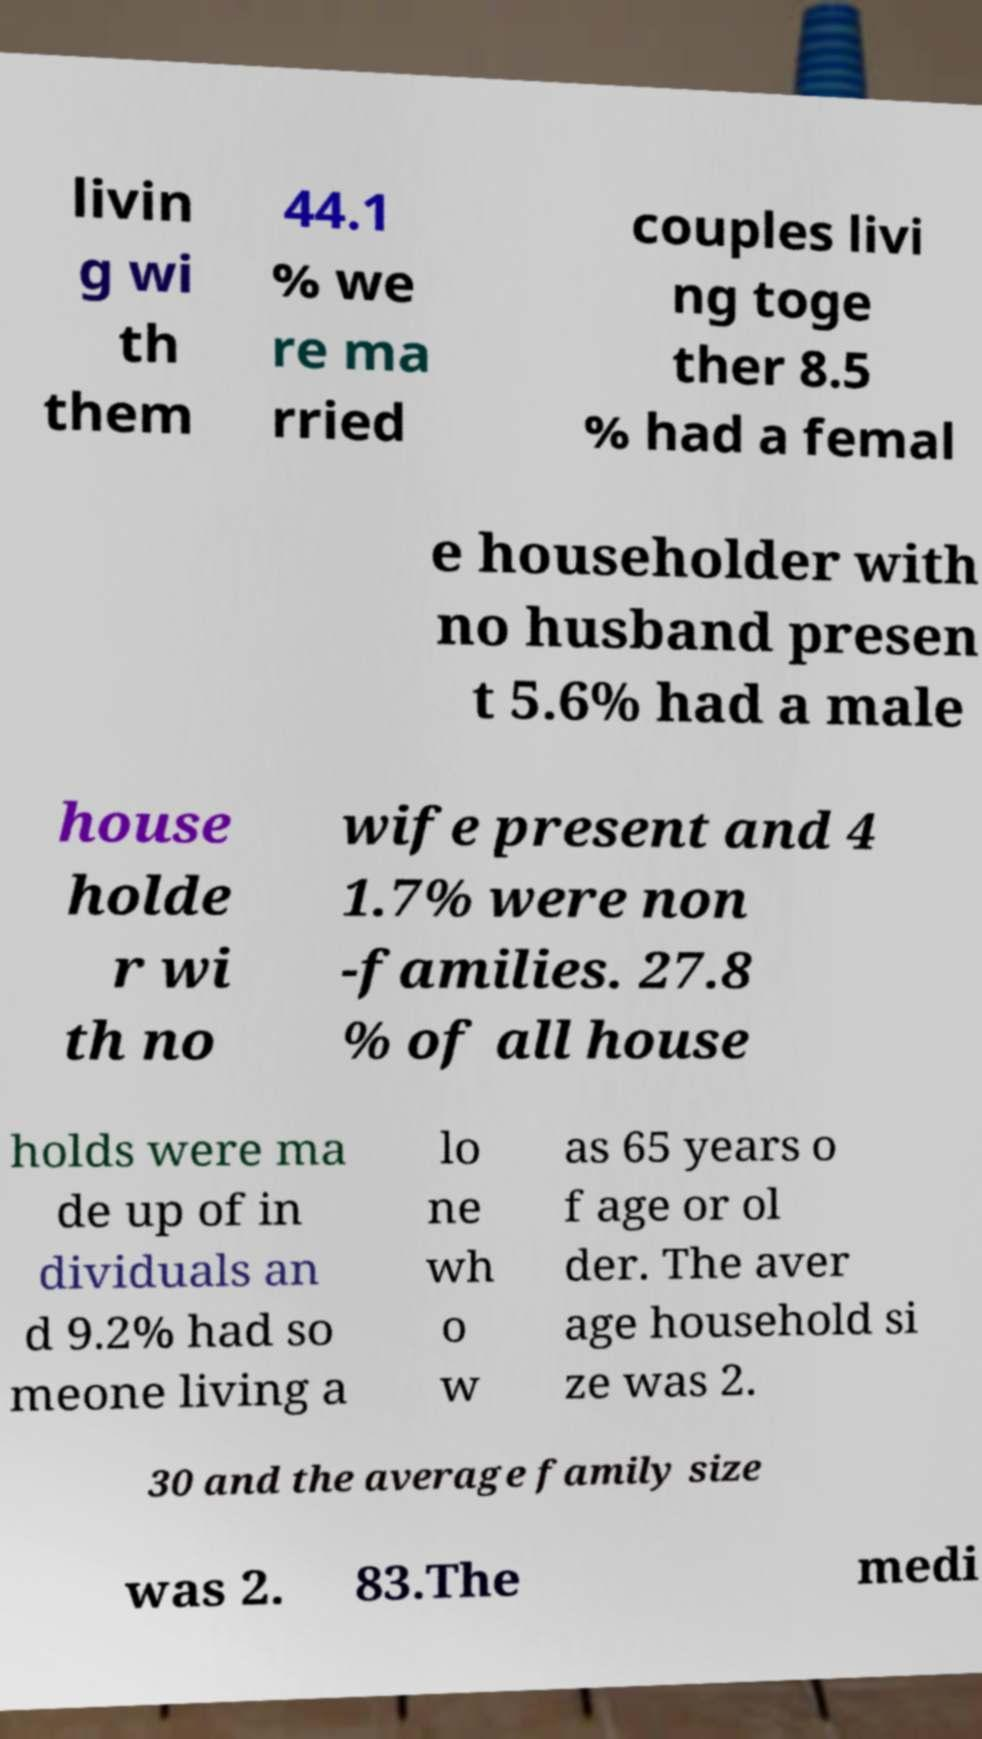For documentation purposes, I need the text within this image transcribed. Could you provide that? livin g wi th them 44.1 % we re ma rried couples livi ng toge ther 8.5 % had a femal e householder with no husband presen t 5.6% had a male house holde r wi th no wife present and 4 1.7% were non -families. 27.8 % of all house holds were ma de up of in dividuals an d 9.2% had so meone living a lo ne wh o w as 65 years o f age or ol der. The aver age household si ze was 2. 30 and the average family size was 2. 83.The medi 